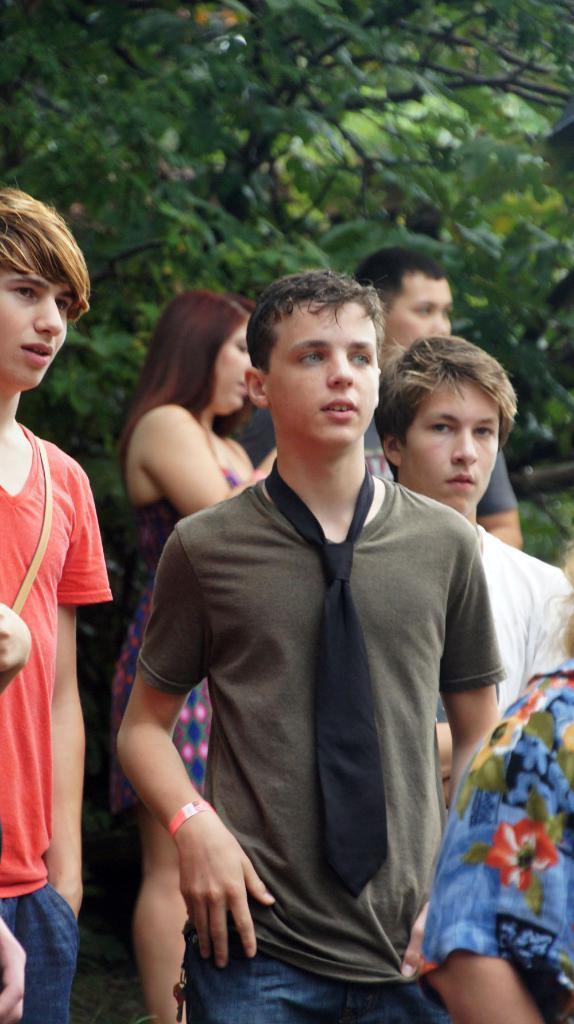Could you give a brief overview of what you see in this image? In the foreground of the picture there are people, behind them there is a woman and a man. In the background there are trees. 